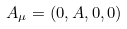Convert formula to latex. <formula><loc_0><loc_0><loc_500><loc_500>A _ { \mu } = ( 0 , A , 0 , 0 )</formula> 